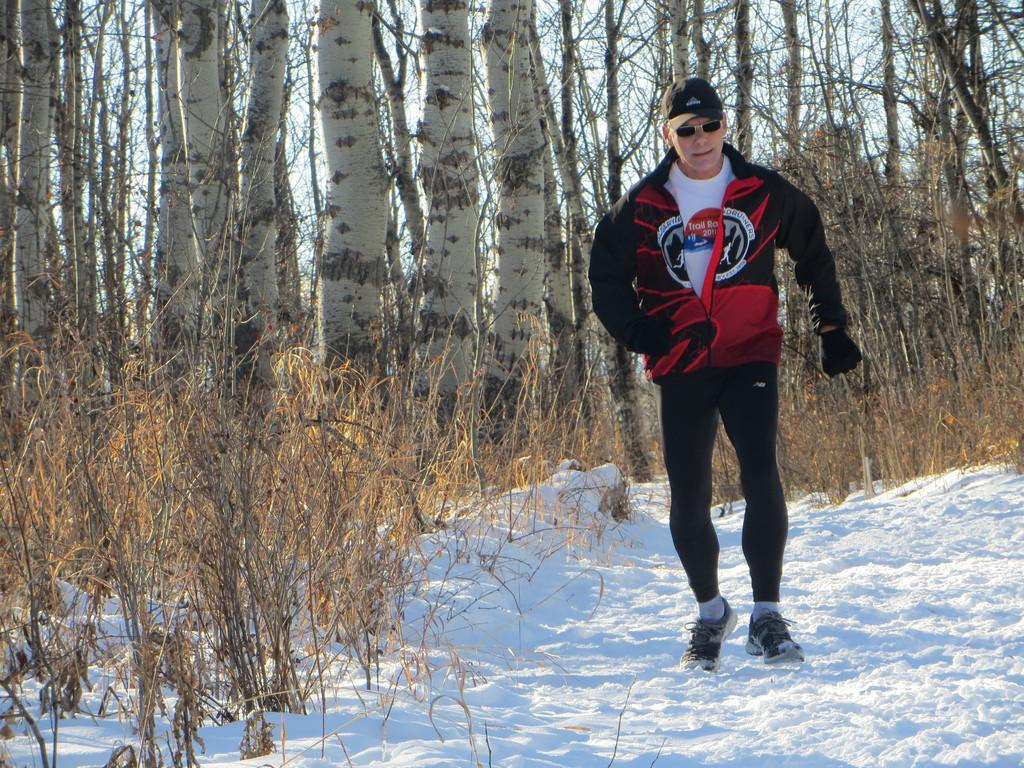Who is present in the image? There is a man in the image. What is the man wearing on his upper body? The man is wearing a sweater. What accessory is the man wearing on his face? The man is wearing glasses. What headwear is the man wearing? The man is wearing a cap. What type of surface is the man walking on? The man is walking on a snow surface. What type of vegetation can be seen in the image? There are plants in the image. What can be seen in the background of the image? There are trees in the background of the image. What type of bird is perched on the man's shoulder in the image? There is no bird present on the man's shoulder in the image. 